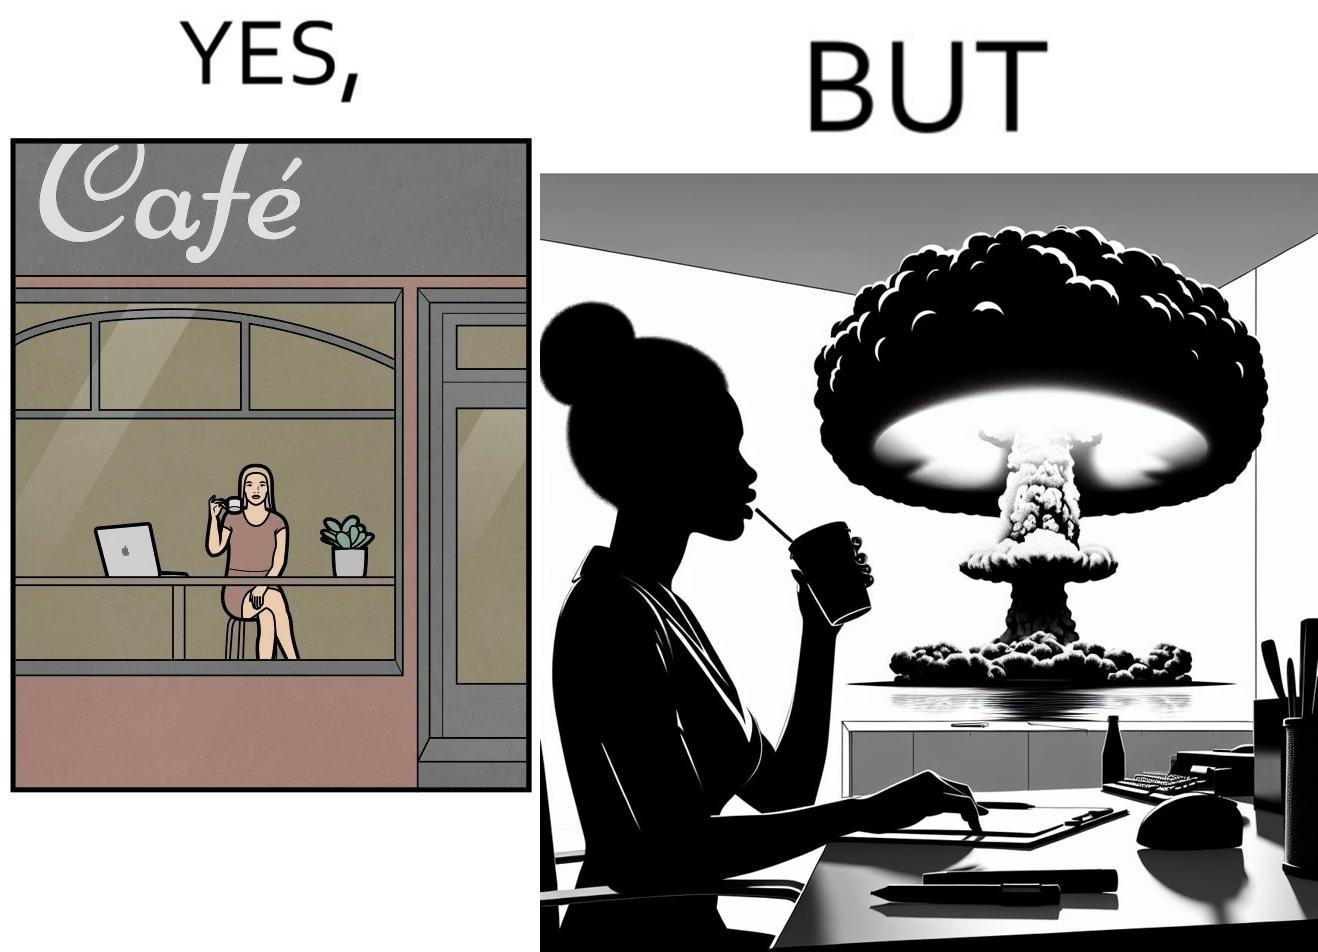What does this image depict? The images are funny since it shows a woman simply sipping from a cup at ease in a cafe with her laptop not caring about anything going on outside the cafe even though the situation is very grave,that is, a nuclear blast 